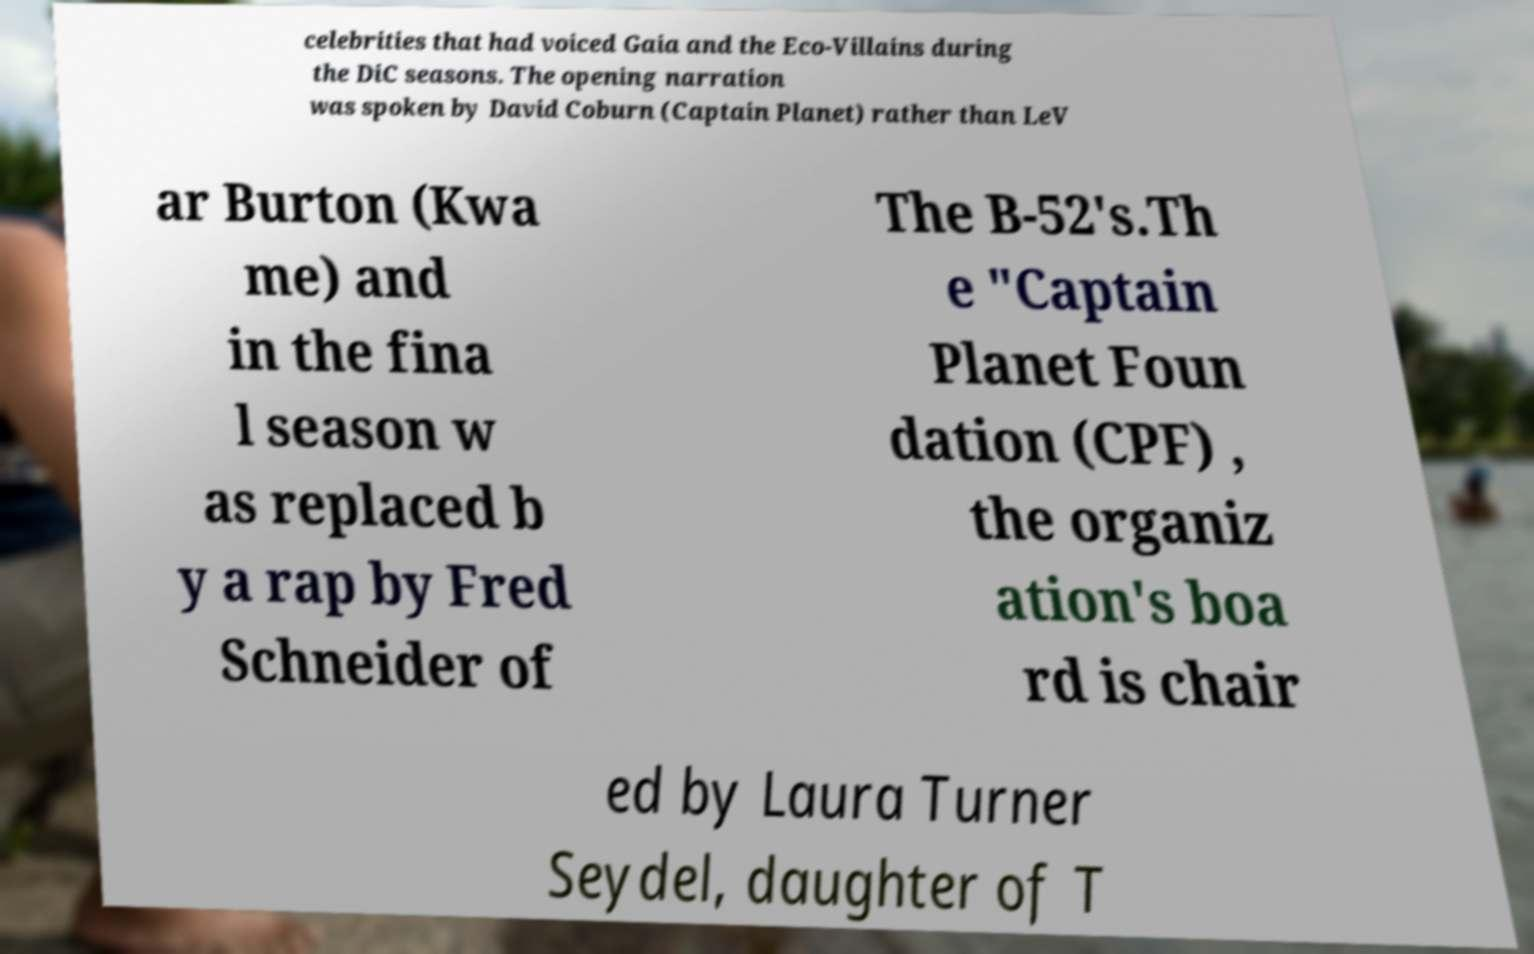Please identify and transcribe the text found in this image. celebrities that had voiced Gaia and the Eco-Villains during the DiC seasons. The opening narration was spoken by David Coburn (Captain Planet) rather than LeV ar Burton (Kwa me) and in the fina l season w as replaced b y a rap by Fred Schneider of The B-52's.Th e "Captain Planet Foun dation (CPF) , the organiz ation's boa rd is chair ed by Laura Turner Seydel, daughter of T 